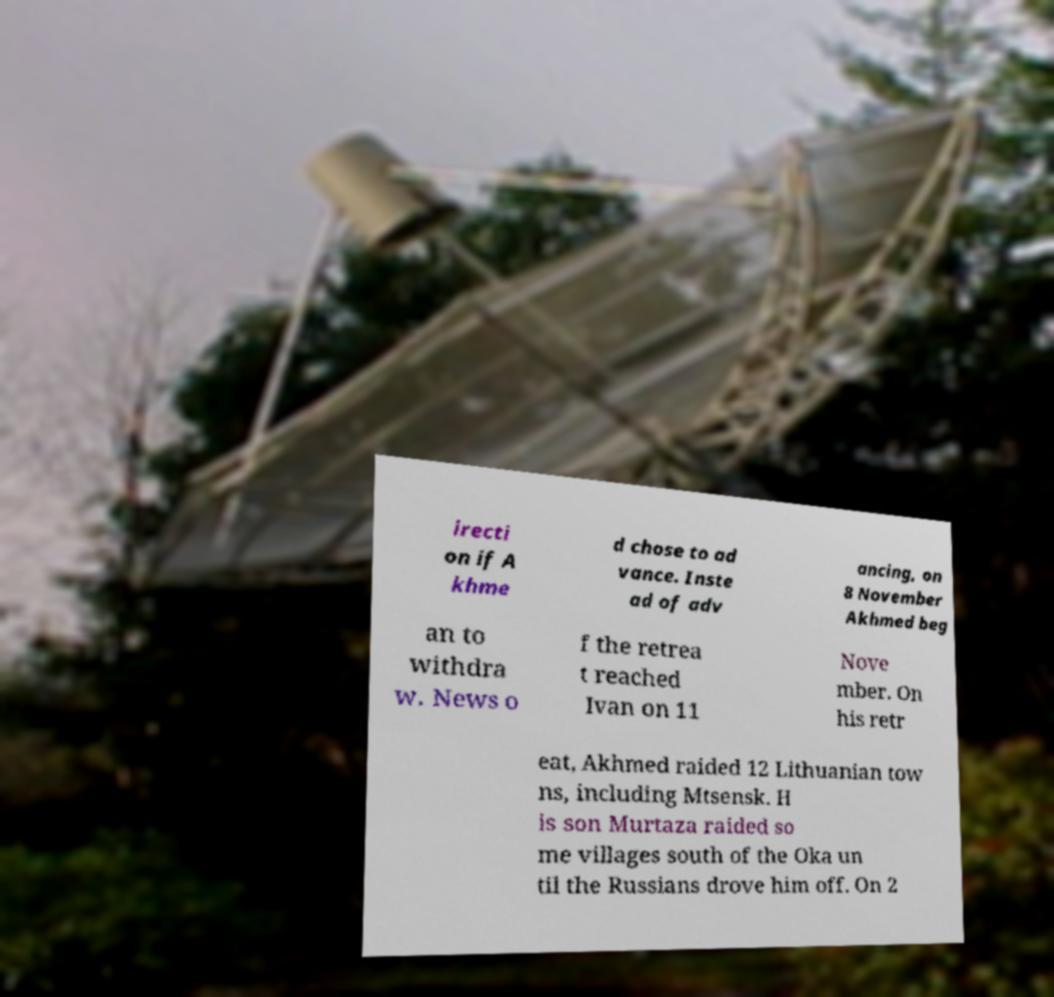There's text embedded in this image that I need extracted. Can you transcribe it verbatim? irecti on if A khme d chose to ad vance. Inste ad of adv ancing, on 8 November Akhmed beg an to withdra w. News o f the retrea t reached Ivan on 11 Nove mber. On his retr eat, Akhmed raided 12 Lithuanian tow ns, including Mtsensk. H is son Murtaza raided so me villages south of the Oka un til the Russians drove him off. On 2 